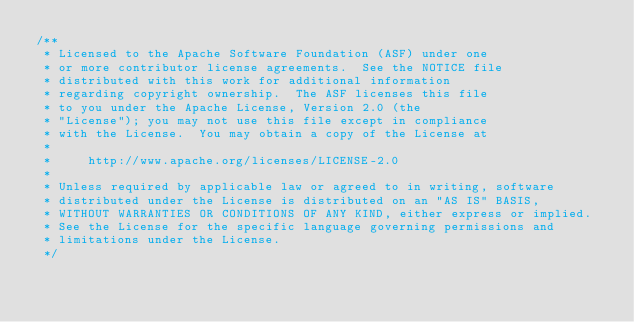<code> <loc_0><loc_0><loc_500><loc_500><_Java_>/**
 * Licensed to the Apache Software Foundation (ASF) under one
 * or more contributor license agreements.  See the NOTICE file
 * distributed with this work for additional information
 * regarding copyright ownership.  The ASF licenses this file
 * to you under the Apache License, Version 2.0 (the
 * "License"); you may not use this file except in compliance
 * with the License.  You may obtain a copy of the License at
 *
 *     http://www.apache.org/licenses/LICENSE-2.0
 *
 * Unless required by applicable law or agreed to in writing, software
 * distributed under the License is distributed on an "AS IS" BASIS,
 * WITHOUT WARRANTIES OR CONDITIONS OF ANY KIND, either express or implied.
 * See the License for the specific language governing permissions and
 * limitations under the License.
 */
</code> 